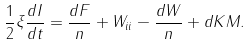Convert formula to latex. <formula><loc_0><loc_0><loc_500><loc_500>\frac { 1 } { 2 } \xi \frac { d I } { d t } = \frac { d F } { n } + W _ { i i } - \frac { d W } { n } + d K M .</formula> 